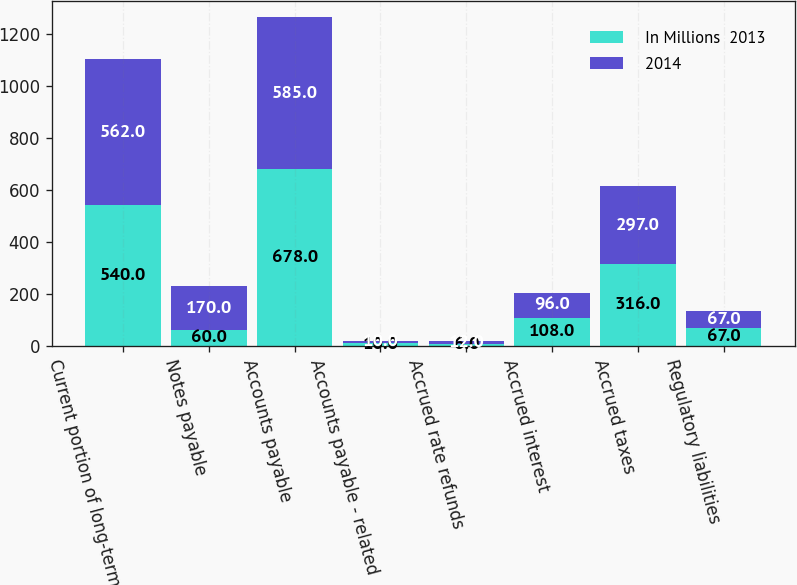Convert chart to OTSL. <chart><loc_0><loc_0><loc_500><loc_500><stacked_bar_chart><ecel><fcel>Current portion of long-term<fcel>Notes payable<fcel>Accounts payable<fcel>Accounts payable - related<fcel>Accrued rate refunds<fcel>Accrued interest<fcel>Accrued taxes<fcel>Regulatory liabilities<nl><fcel>In Millions  2013<fcel>540<fcel>60<fcel>678<fcel>10<fcel>6<fcel>108<fcel>316<fcel>67<nl><fcel>2014<fcel>562<fcel>170<fcel>585<fcel>10<fcel>12<fcel>96<fcel>297<fcel>67<nl></chart> 